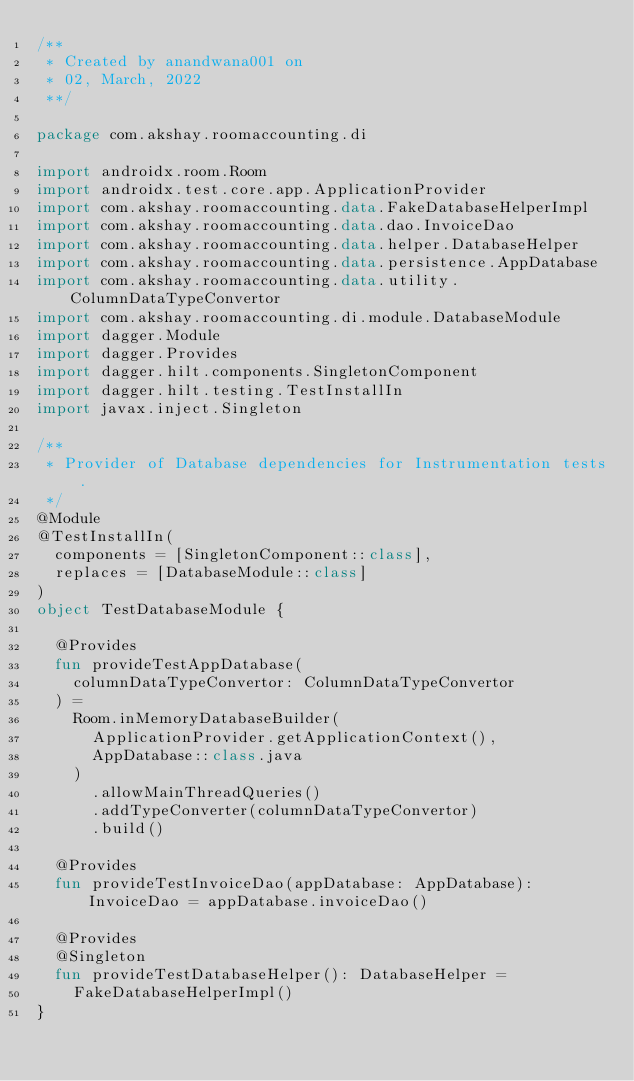<code> <loc_0><loc_0><loc_500><loc_500><_Kotlin_>/**
 * Created by anandwana001 on
 * 02, March, 2022
 **/

package com.akshay.roomaccounting.di

import androidx.room.Room
import androidx.test.core.app.ApplicationProvider
import com.akshay.roomaccounting.data.FakeDatabaseHelperImpl
import com.akshay.roomaccounting.data.dao.InvoiceDao
import com.akshay.roomaccounting.data.helper.DatabaseHelper
import com.akshay.roomaccounting.data.persistence.AppDatabase
import com.akshay.roomaccounting.data.utility.ColumnDataTypeConvertor
import com.akshay.roomaccounting.di.module.DatabaseModule
import dagger.Module
import dagger.Provides
import dagger.hilt.components.SingletonComponent
import dagger.hilt.testing.TestInstallIn
import javax.inject.Singleton

/**
 * Provider of Database dependencies for Instrumentation tests.
 */
@Module
@TestInstallIn(
  components = [SingletonComponent::class],
  replaces = [DatabaseModule::class]
)
object TestDatabaseModule {

  @Provides
  fun provideTestAppDatabase(
    columnDataTypeConvertor: ColumnDataTypeConvertor
  ) =
    Room.inMemoryDatabaseBuilder(
      ApplicationProvider.getApplicationContext(),
      AppDatabase::class.java
    )
      .allowMainThreadQueries()
      .addTypeConverter(columnDataTypeConvertor)
      .build()

  @Provides
  fun provideTestInvoiceDao(appDatabase: AppDatabase): InvoiceDao = appDatabase.invoiceDao()

  @Provides
  @Singleton
  fun provideTestDatabaseHelper(): DatabaseHelper =
    FakeDatabaseHelperImpl()
}
</code> 